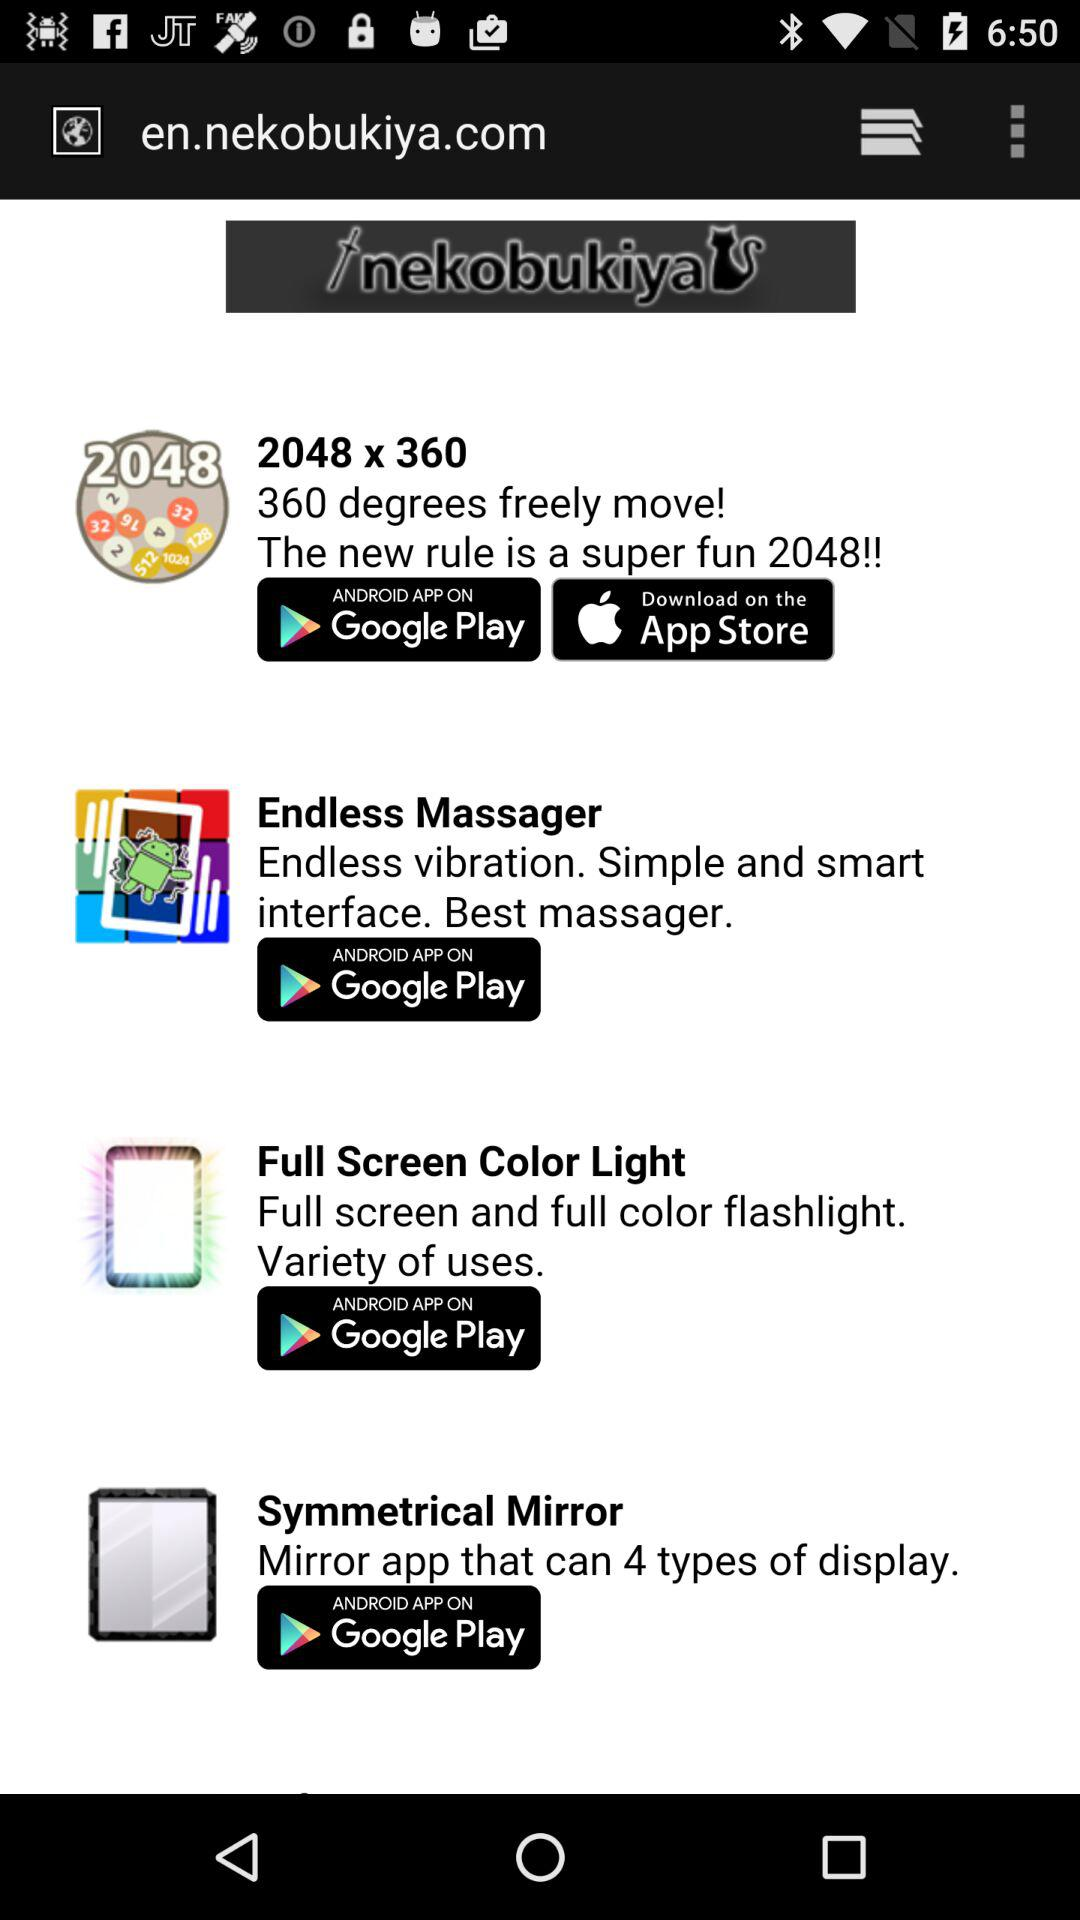Name the app that has a full screen and a full color flashlight? The app is "Full Screen Color Light". 